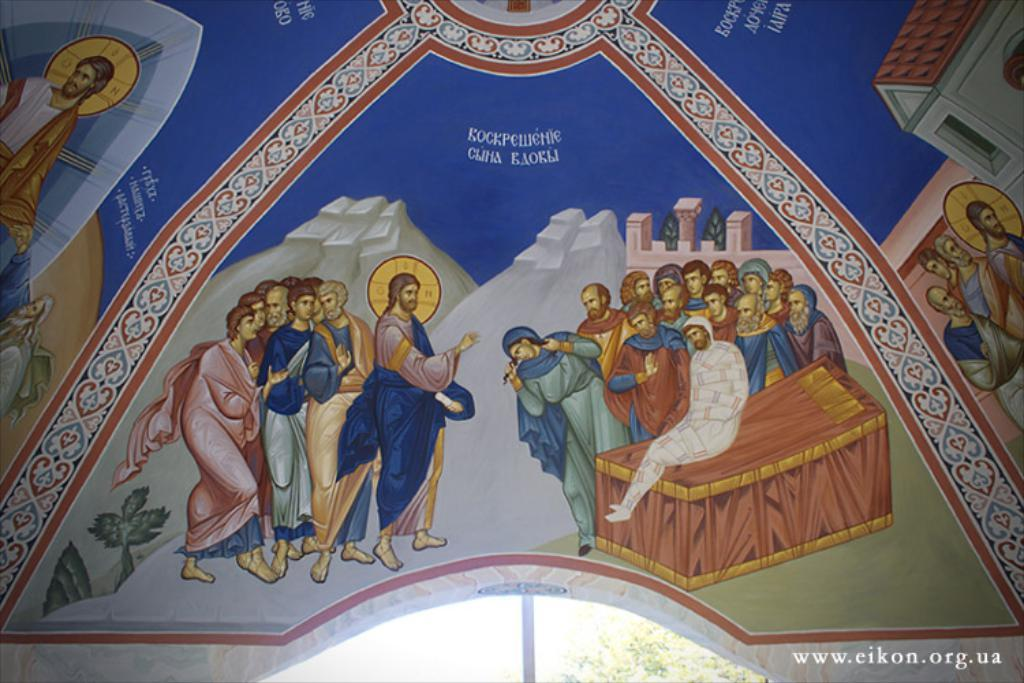What types of paintings are visible in the image? There are: There are paintings of people, houses, plants, and walls in the image. Can you describe the person sitting on an object in the image? There is a person sitting on an object in the image, but the facts do not provide any details about the person's appearance or the object they are sitting on. What can be seen in the background of the image? There is a tree visible in the background of the image. What type of needle is being used to sew the brick in the image? There is no needle or brick present in the image; the facts mention paintings of walls, but not bricks or sewing. 